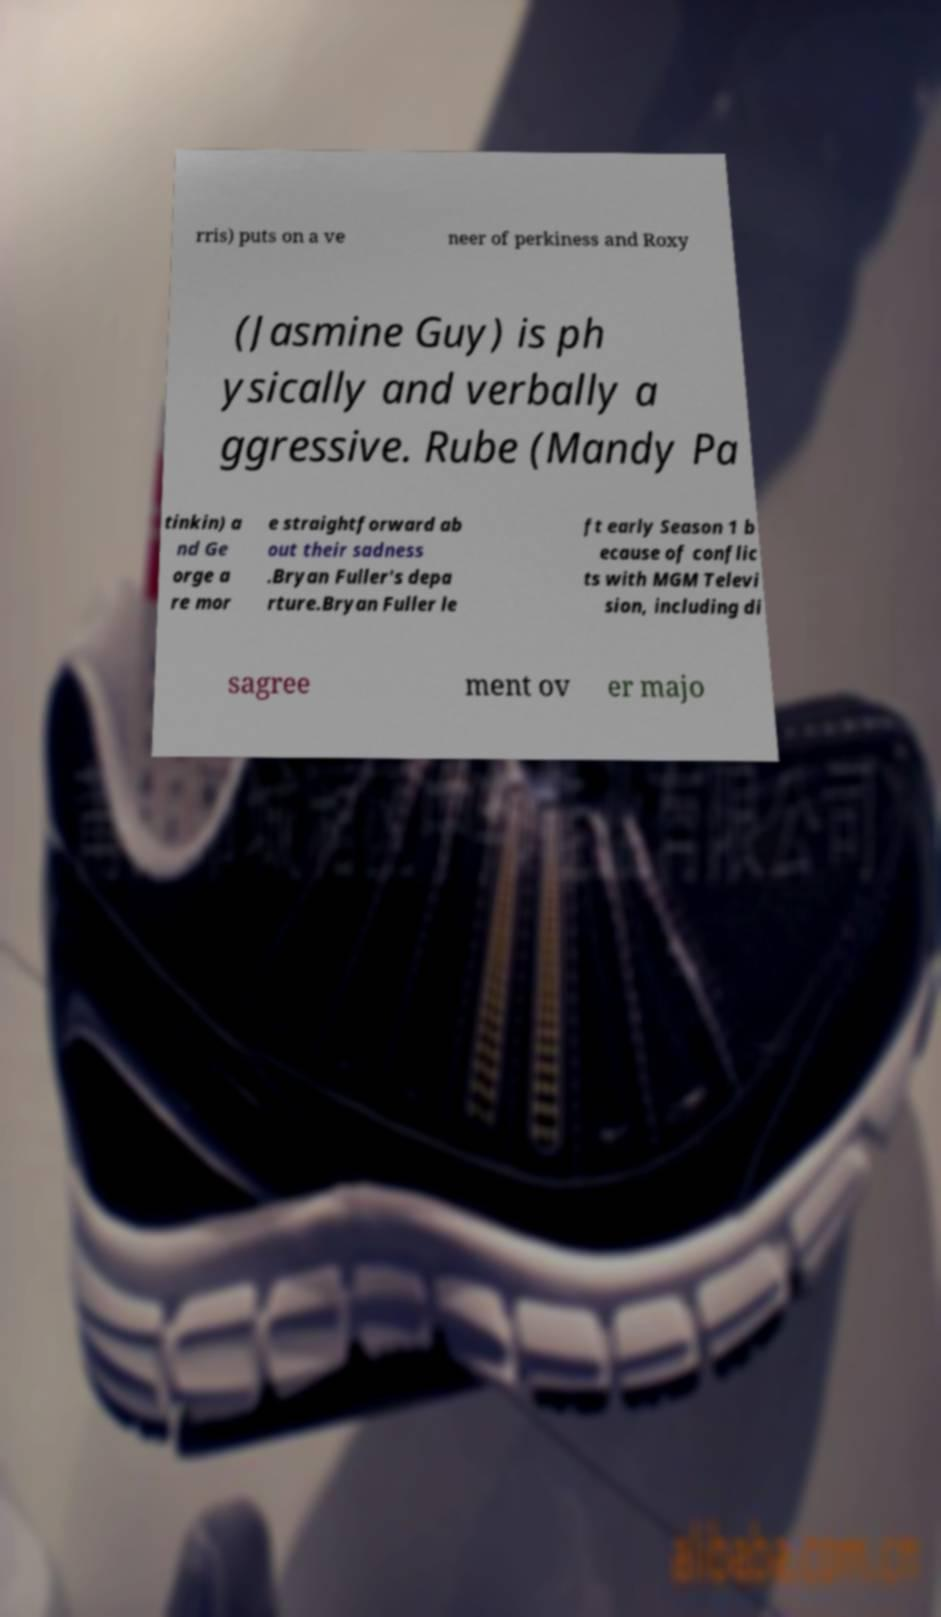Please read and relay the text visible in this image. What does it say? rris) puts on a ve neer of perkiness and Roxy (Jasmine Guy) is ph ysically and verbally a ggressive. Rube (Mandy Pa tinkin) a nd Ge orge a re mor e straightforward ab out their sadness .Bryan Fuller's depa rture.Bryan Fuller le ft early Season 1 b ecause of conflic ts with MGM Televi sion, including di sagree ment ov er majo 